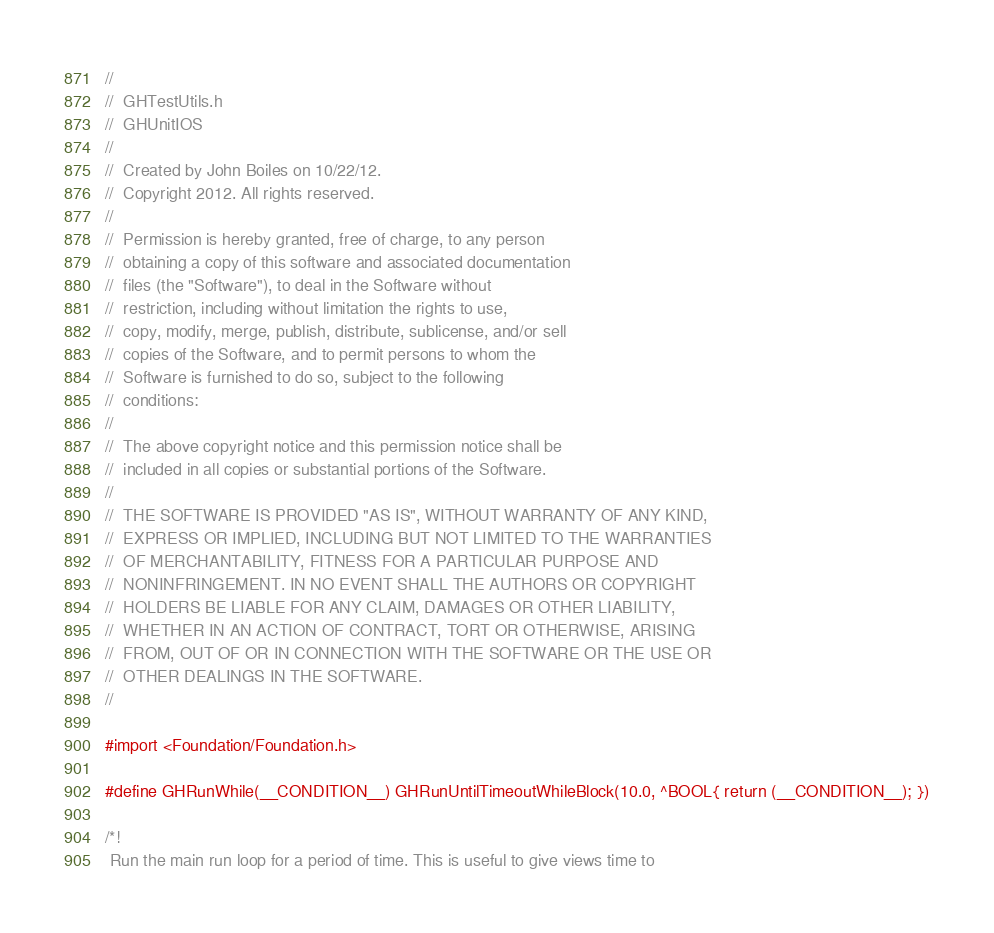<code> <loc_0><loc_0><loc_500><loc_500><_C_>//
//  GHTestUtils.h
//  GHUnitIOS
//
//  Created by John Boiles on 10/22/12.
//  Copyright 2012. All rights reserved.
//
//  Permission is hereby granted, free of charge, to any person
//  obtaining a copy of this software and associated documentation
//  files (the "Software"), to deal in the Software without
//  restriction, including without limitation the rights to use,
//  copy, modify, merge, publish, distribute, sublicense, and/or sell
//  copies of the Software, and to permit persons to whom the
//  Software is furnished to do so, subject to the following
//  conditions:
//
//  The above copyright notice and this permission notice shall be
//  included in all copies or substantial portions of the Software.
//
//  THE SOFTWARE IS PROVIDED "AS IS", WITHOUT WARRANTY OF ANY KIND,
//  EXPRESS OR IMPLIED, INCLUDING BUT NOT LIMITED TO THE WARRANTIES
//  OF MERCHANTABILITY, FITNESS FOR A PARTICULAR PURPOSE AND
//  NONINFRINGEMENT. IN NO EVENT SHALL THE AUTHORS OR COPYRIGHT
//  HOLDERS BE LIABLE FOR ANY CLAIM, DAMAGES OR OTHER LIABILITY,
//  WHETHER IN AN ACTION OF CONTRACT, TORT OR OTHERWISE, ARISING
//  FROM, OUT OF OR IN CONNECTION WITH THE SOFTWARE OR THE USE OR
//  OTHER DEALINGS IN THE SOFTWARE.
//

#import <Foundation/Foundation.h>

#define GHRunWhile(__CONDITION__) GHRunUntilTimeoutWhileBlock(10.0, ^BOOL{ return (__CONDITION__); })

/*!
 Run the main run loop for a period of time. This is useful to give views time to</code> 